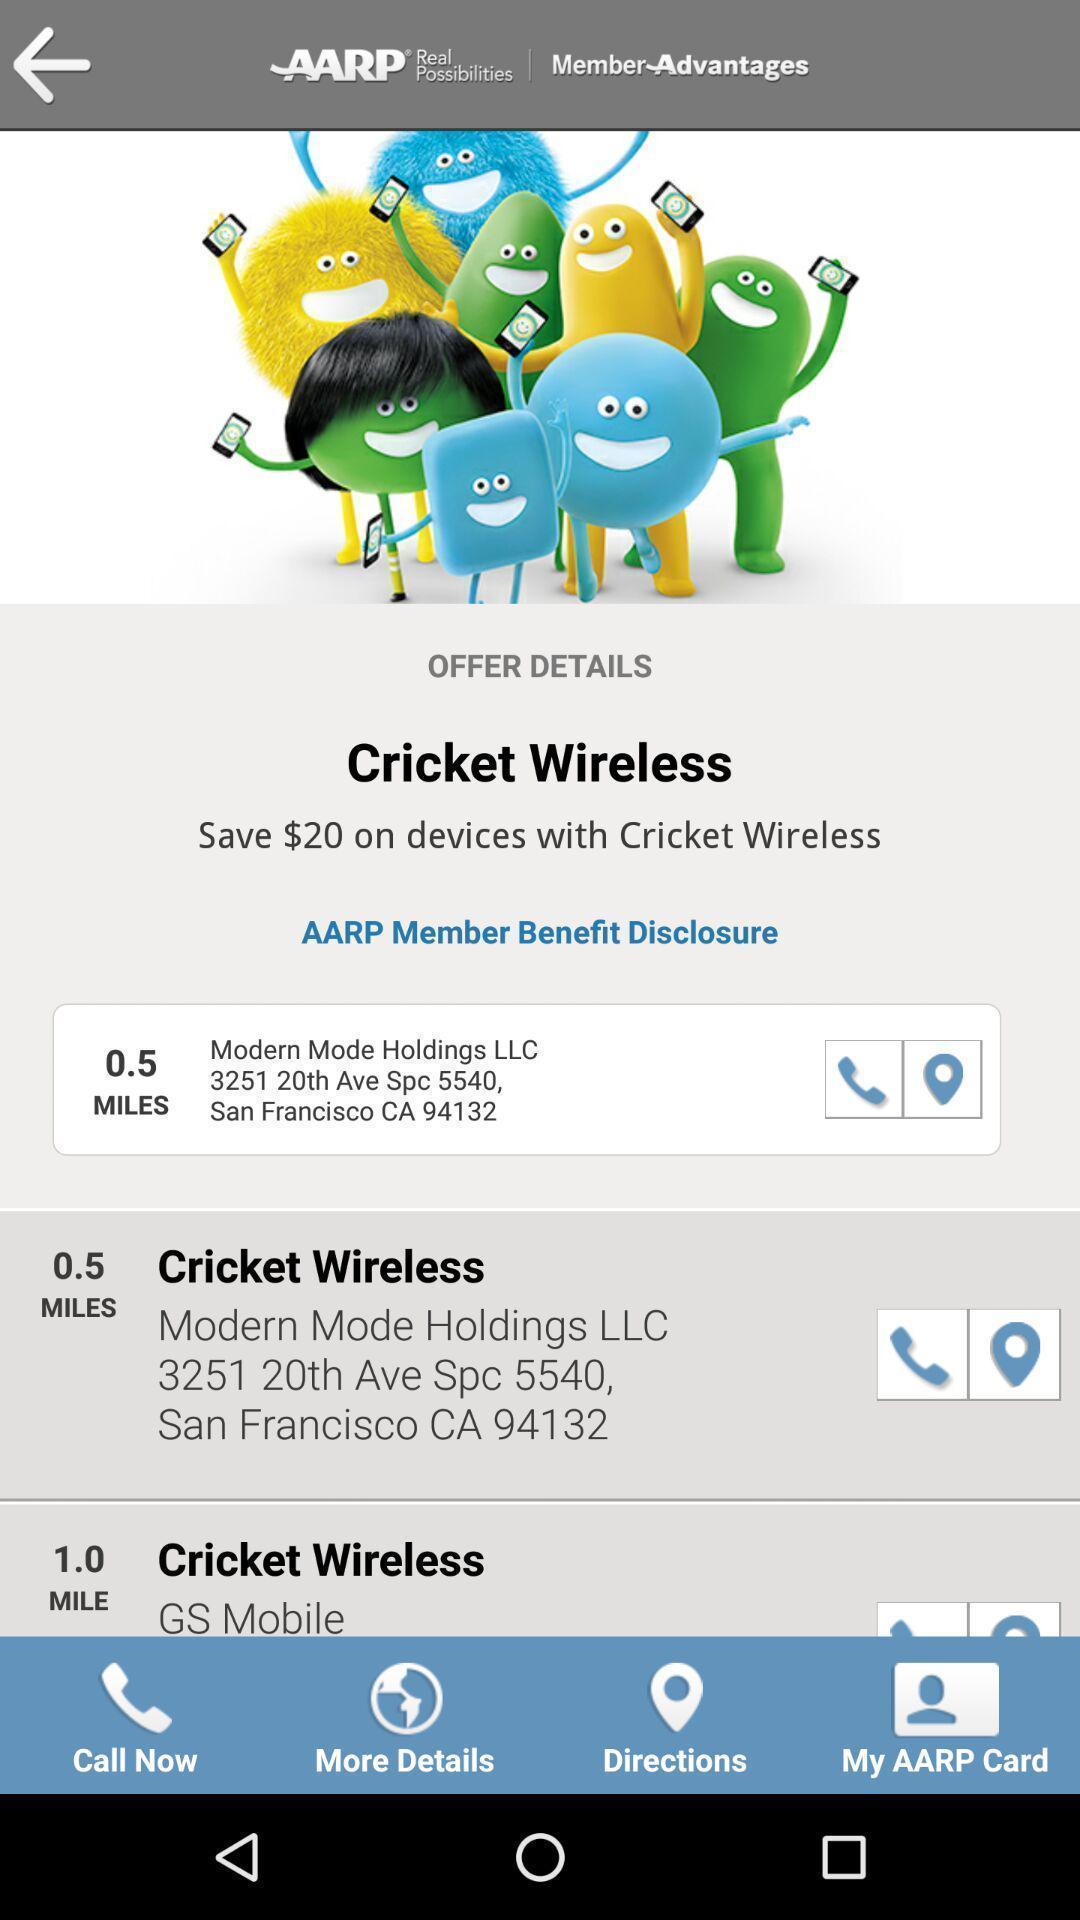Summarize the information in this screenshot. Page showing list of different addresses. 